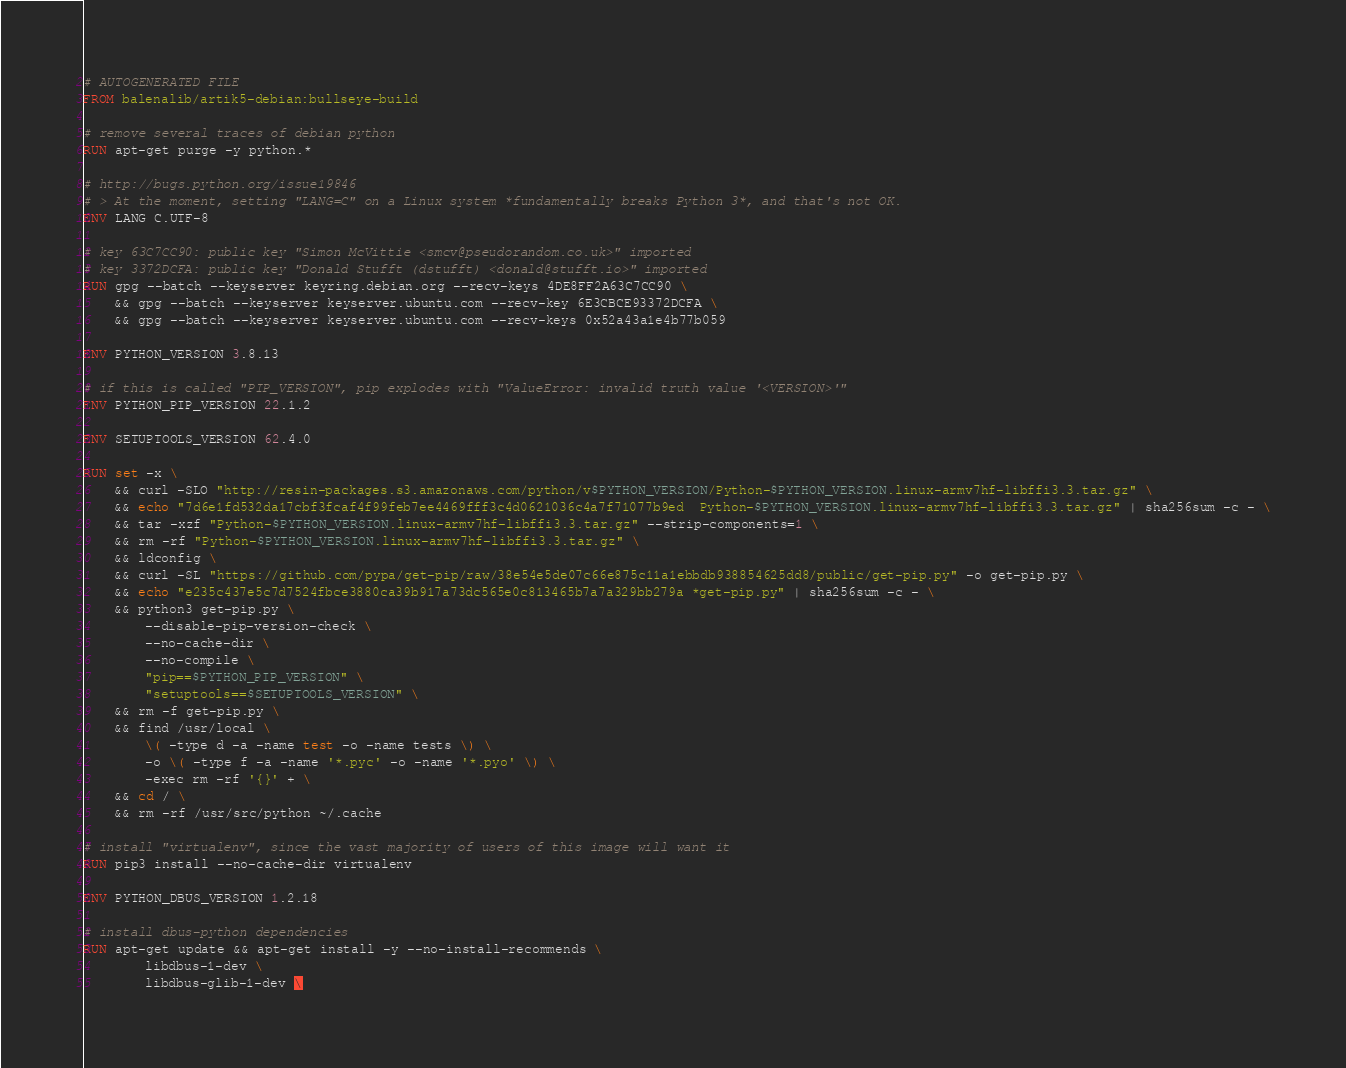<code> <loc_0><loc_0><loc_500><loc_500><_Dockerfile_># AUTOGENERATED FILE
FROM balenalib/artik5-debian:bullseye-build

# remove several traces of debian python
RUN apt-get purge -y python.*

# http://bugs.python.org/issue19846
# > At the moment, setting "LANG=C" on a Linux system *fundamentally breaks Python 3*, and that's not OK.
ENV LANG C.UTF-8

# key 63C7CC90: public key "Simon McVittie <smcv@pseudorandom.co.uk>" imported
# key 3372DCFA: public key "Donald Stufft (dstufft) <donald@stufft.io>" imported
RUN gpg --batch --keyserver keyring.debian.org --recv-keys 4DE8FF2A63C7CC90 \
    && gpg --batch --keyserver keyserver.ubuntu.com --recv-key 6E3CBCE93372DCFA \
    && gpg --batch --keyserver keyserver.ubuntu.com --recv-keys 0x52a43a1e4b77b059

ENV PYTHON_VERSION 3.8.13

# if this is called "PIP_VERSION", pip explodes with "ValueError: invalid truth value '<VERSION>'"
ENV PYTHON_PIP_VERSION 22.1.2

ENV SETUPTOOLS_VERSION 62.4.0

RUN set -x \
    && curl -SLO "http://resin-packages.s3.amazonaws.com/python/v$PYTHON_VERSION/Python-$PYTHON_VERSION.linux-armv7hf-libffi3.3.tar.gz" \
    && echo "7d6e1fd532da17cbf3fcaf4f99feb7ee4469fff3c4d0621036c4a7f71077b9ed  Python-$PYTHON_VERSION.linux-armv7hf-libffi3.3.tar.gz" | sha256sum -c - \
    && tar -xzf "Python-$PYTHON_VERSION.linux-armv7hf-libffi3.3.tar.gz" --strip-components=1 \
    && rm -rf "Python-$PYTHON_VERSION.linux-armv7hf-libffi3.3.tar.gz" \
    && ldconfig \
    && curl -SL "https://github.com/pypa/get-pip/raw/38e54e5de07c66e875c11a1ebbdb938854625dd8/public/get-pip.py" -o get-pip.py \
    && echo "e235c437e5c7d7524fbce3880ca39b917a73dc565e0c813465b7a7a329bb279a *get-pip.py" | sha256sum -c - \
    && python3 get-pip.py \
        --disable-pip-version-check \
        --no-cache-dir \
        --no-compile \
        "pip==$PYTHON_PIP_VERSION" \
        "setuptools==$SETUPTOOLS_VERSION" \
    && rm -f get-pip.py \
    && find /usr/local \
        \( -type d -a -name test -o -name tests \) \
        -o \( -type f -a -name '*.pyc' -o -name '*.pyo' \) \
        -exec rm -rf '{}' + \
    && cd / \
    && rm -rf /usr/src/python ~/.cache

# install "virtualenv", since the vast majority of users of this image will want it
RUN pip3 install --no-cache-dir virtualenv

ENV PYTHON_DBUS_VERSION 1.2.18

# install dbus-python dependencies 
RUN apt-get update && apt-get install -y --no-install-recommends \
		libdbus-1-dev \
		libdbus-glib-1-dev \</code> 